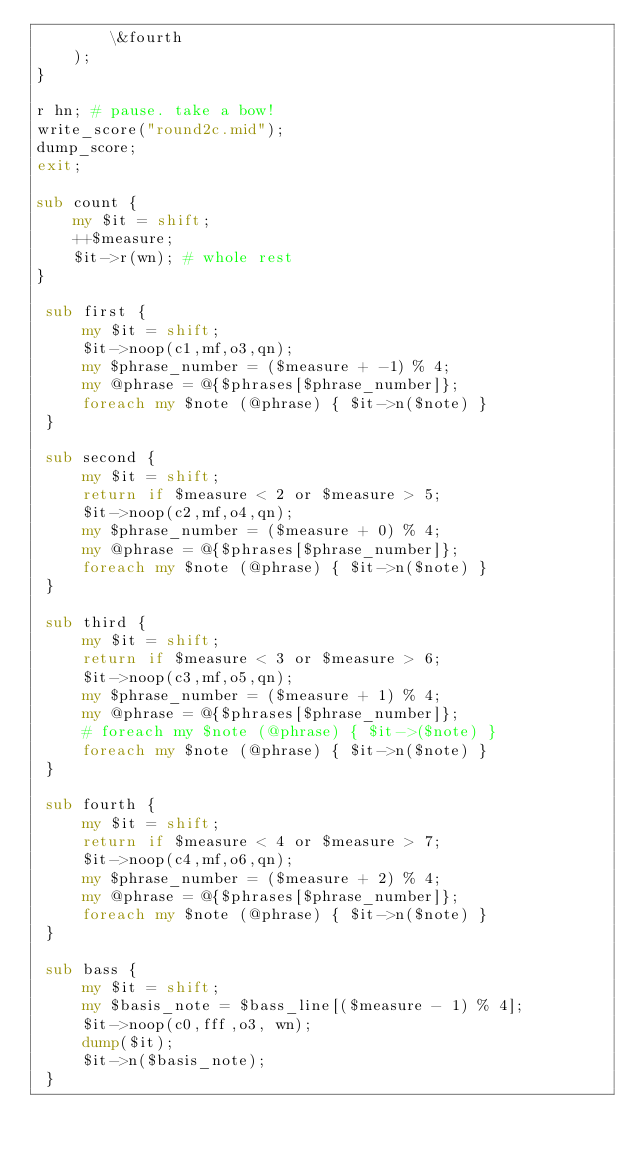Convert code to text. <code><loc_0><loc_0><loc_500><loc_500><_Perl_>	    \&fourth
	);
}

r hn; # pause. take a bow!
write_score("round2c.mid");
dump_score;
exit;

sub count {
    my $it = shift;
    ++$measure;
    $it->r(wn); # whole rest
}

 sub first {
     my $it = shift;
     $it->noop(c1,mf,o3,qn);
     my $phrase_number = ($measure + -1) % 4;
     my @phrase = @{$phrases[$phrase_number]};
     foreach my $note (@phrase) { $it->n($note) }
 }

 sub second {
     my $it = shift;
     return if $measure < 2 or $measure > 5;
     $it->noop(c2,mf,o4,qn);
     my $phrase_number = ($measure + 0) % 4;
     my @phrase = @{$phrases[$phrase_number]};
     foreach my $note (@phrase) { $it->n($note) }
 }

 sub third {
     my $it = shift;
     return if $measure < 3 or $measure > 6;
     $it->noop(c3,mf,o5,qn);
     my $phrase_number = ($measure + 1) % 4;
     my @phrase = @{$phrases[$phrase_number]};
     # foreach my $note (@phrase) { $it->($note) }
     foreach my $note (@phrase) { $it->n($note) }
 }

 sub fourth {
     my $it = shift;
     return if $measure < 4 or $measure > 7;
     $it->noop(c4,mf,o6,qn);
     my $phrase_number = ($measure + 2) % 4;
     my @phrase = @{$phrases[$phrase_number]};
     foreach my $note (@phrase) { $it->n($note) }
 }

 sub bass {
     my $it = shift;
     my $basis_note = $bass_line[($measure - 1) % 4];
     $it->noop(c0,fff,o3, wn); 
     dump($it);
     $it->n($basis_note);
 }
</code> 